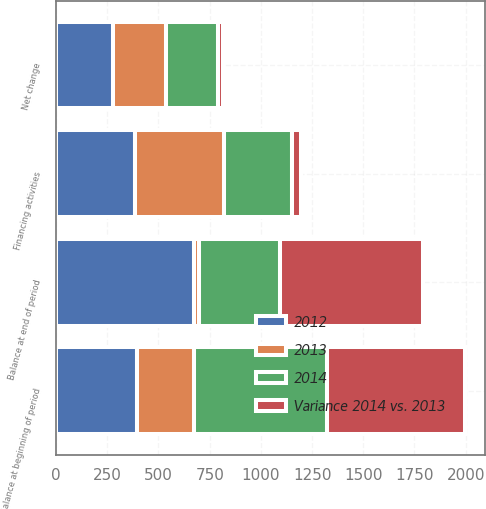Convert chart. <chart><loc_0><loc_0><loc_500><loc_500><stacked_bar_chart><ecel><fcel>Financing activities<fcel>Net change<fcel>Balance at beginning of period<fcel>Balance at end of period<nl><fcel>Variance 2014 vs. 2013<fcel>47<fcel>25<fcel>674<fcel>699<nl><fcel>2012<fcel>387<fcel>280<fcel>394<fcel>674<nl><fcel>2013<fcel>434<fcel>255<fcel>280<fcel>25<nl><fcel>2014<fcel>330<fcel>254<fcel>648<fcel>394<nl></chart> 